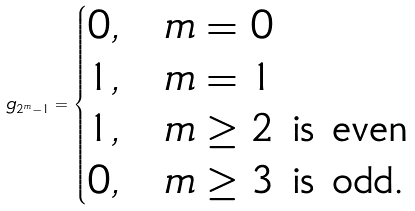Convert formula to latex. <formula><loc_0><loc_0><loc_500><loc_500>g _ { 2 ^ { m } - 1 } = \begin{cases} 0 , & \text {$m=0$} \\ 1 , & \text {$m=1$} \\ 1 , & \text {$m\geq2$ is even} \\ 0 , & \text {$m\geq3$ is odd.} \end{cases}</formula> 